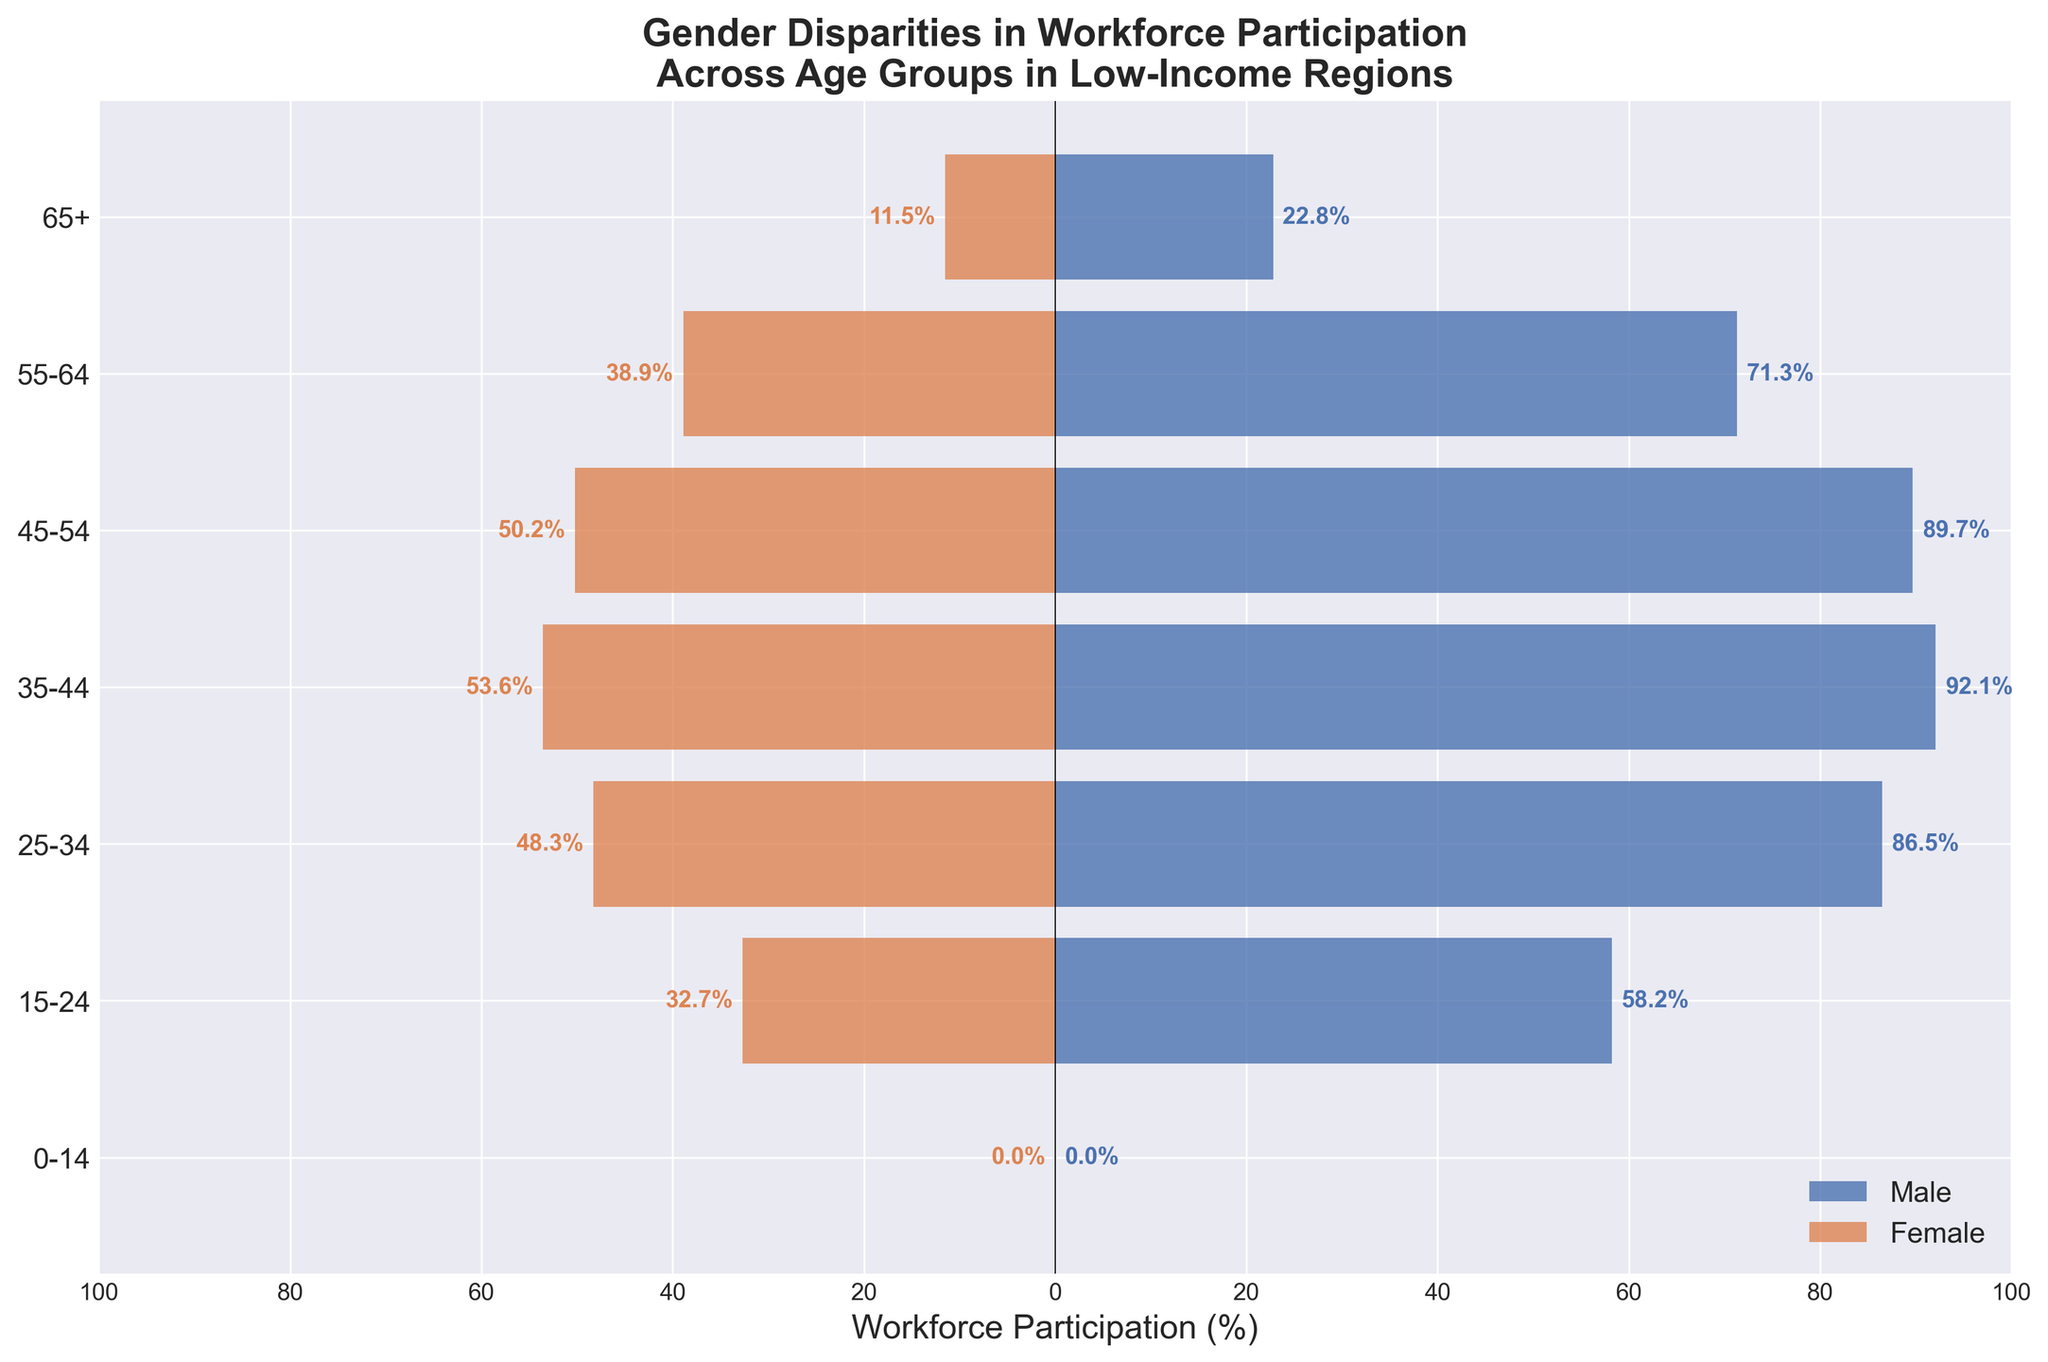What is the title of the figure? The title of the figure is usually prominently displayed at the top. Here, the title reads 'Gender Disparities in Workforce Participation Across Age Groups in Low-Income Regions'.
Answer: Gender Disparities in Workforce Participation Across Age Groups in Low-Income Regions Which age group has the highest male workforce participation? By observing the lengths of the bars on the right side (representing male participation), the bar corresponding to the 35-44 age group is the longest. Therefore, males aged 35-44 have the highest workforce participation rate at 92.1%.
Answer: 35-44 What is the female workforce participation rate for the 25-34 age group? The figure shows horizontal bars extending to the left for female participation. The bar for the 25-34 age group extends to 48.3%.
Answer: 48.3% How does male participation for the 45-54 age group compare to female participation for the same group? The male participation bar for 45-54 extends to 89.7%, while the female bar extends to 50.2%. This shows that male participation is significantly higher than female participation in this age group.
Answer: Male participation is higher What is the combined workforce participation rate (male + female) for the 55-64 age group? Male participation for 55-64 is 71.3% and female participation is 38.9%. Adding these together, we get 71.3 + 38.9 = 110.2%.
Answer: 110.2% How does workforce participation among males and females change as they move from the 25-34 age group to the 35-44 age group? Comparing the bars for the two age groups: Male participation increases from 86.5% (25-34) to 92.1% (35-44), while female participation increases from 48.3% (25-34) to 53.6% (35-44). Both genders see an increase in workforce participation.
Answer: Both increase Which age group shows the smallest gender disparity in workforce participation? The age group with the bars for male and female participation closest in length indicates the smallest disparity. The 15-24 age group has a relatively smaller disparity with male participation at 58.2% and female at 32.7%, but the 65+ group has a close participation (22.8% for males and 11.5% for females) so the disparity is smallest there.
Answer: 65+ What is the average female workforce participation rate across all age groups? Summing the female participation rates: 0% (0-14) + 32.7% (15-24) + 48.3% (25-34) + 53.6% (35-44) + 50.2% (45-54) + 38.9% (55-64) + 11.5% (65+) = 235.2%. There are 7 age groups, so 235.2 / 7 = 33.6%.
Answer: 33.6% What notable trend can be observed in workforce participation as age increases? There is a general trend that male participation rates are consistently higher than female rates across all age groups. Additionally, participation peaks around the 35-44 age group and then decreases for both genders as age increases.
Answer: Decreases with age 